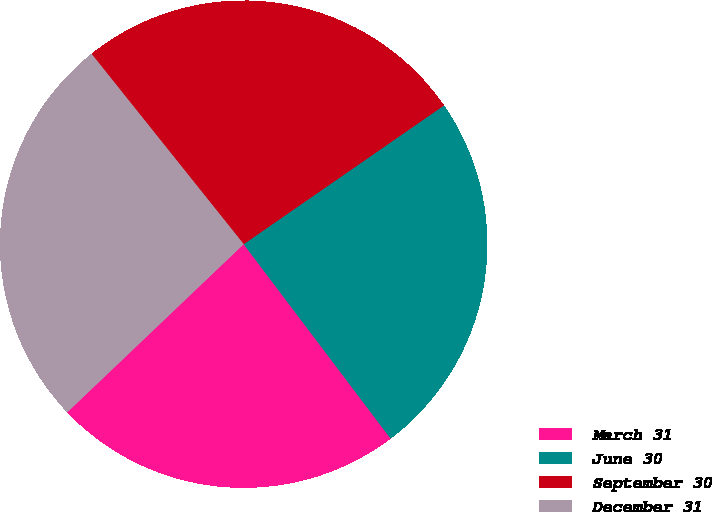Convert chart. <chart><loc_0><loc_0><loc_500><loc_500><pie_chart><fcel>March 31<fcel>June 30<fcel>September 30<fcel>December 31<nl><fcel>23.18%<fcel>24.34%<fcel>26.09%<fcel>26.38%<nl></chart> 